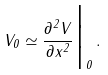<formula> <loc_0><loc_0><loc_500><loc_500>V _ { 0 } \simeq { \frac { \partial ^ { 2 } V } { \partial x ^ { 2 } } } \Big | _ { 0 } \, .</formula> 